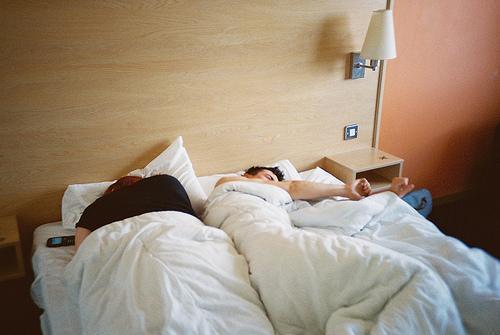How many people in the bed?
Give a very brief answer. 2. 